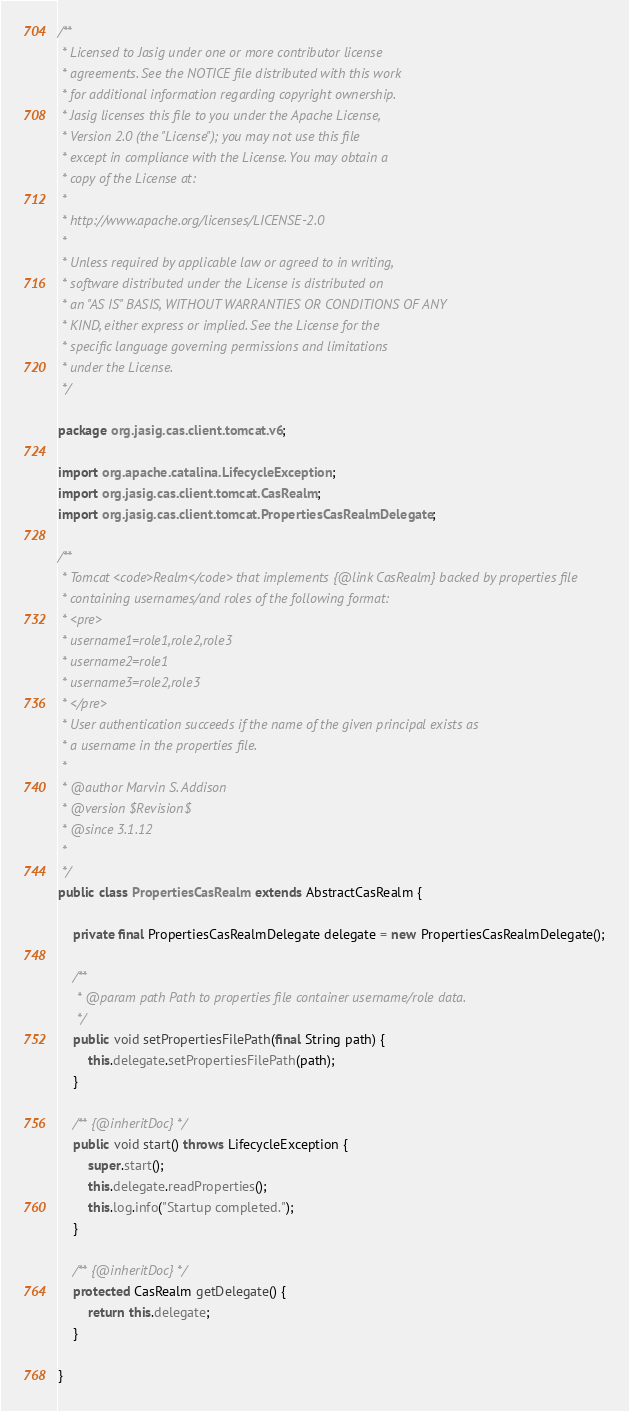<code> <loc_0><loc_0><loc_500><loc_500><_Java_>/**
 * Licensed to Jasig under one or more contributor license
 * agreements. See the NOTICE file distributed with this work
 * for additional information regarding copyright ownership.
 * Jasig licenses this file to you under the Apache License,
 * Version 2.0 (the "License"); you may not use this file
 * except in compliance with the License. You may obtain a
 * copy of the License at:
 *
 * http://www.apache.org/licenses/LICENSE-2.0
 *
 * Unless required by applicable law or agreed to in writing,
 * software distributed under the License is distributed on
 * an "AS IS" BASIS, WITHOUT WARRANTIES OR CONDITIONS OF ANY
 * KIND, either express or implied. See the License for the
 * specific language governing permissions and limitations
 * under the License.
 */

package org.jasig.cas.client.tomcat.v6;

import org.apache.catalina.LifecycleException;
import org.jasig.cas.client.tomcat.CasRealm;
import org.jasig.cas.client.tomcat.PropertiesCasRealmDelegate;

/**
 * Tomcat <code>Realm</code> that implements {@link CasRealm} backed by properties file
 * containing usernames/and roles of the following format:
 * <pre>
 * username1=role1,role2,role3
 * username2=role1
 * username3=role2,role3
 * </pre>
 * User authentication succeeds if the name of the given principal exists as
 * a username in the properties file.
 *
 * @author Marvin S. Addison
 * @version $Revision$
 * @since 3.1.12
 *
 */
public class PropertiesCasRealm extends AbstractCasRealm {

    private final PropertiesCasRealmDelegate delegate = new PropertiesCasRealmDelegate();

    /**
     * @param path Path to properties file container username/role data.
     */
    public void setPropertiesFilePath(final String path) {
        this.delegate.setPropertiesFilePath(path);
    }
    
    /** {@inheritDoc} */
    public void start() throws LifecycleException {
        super.start();
        this.delegate.readProperties();
        this.log.info("Startup completed.");
    }

    /** {@inheritDoc} */
    protected CasRealm getDelegate() {
        return this.delegate;
    }

}
</code> 